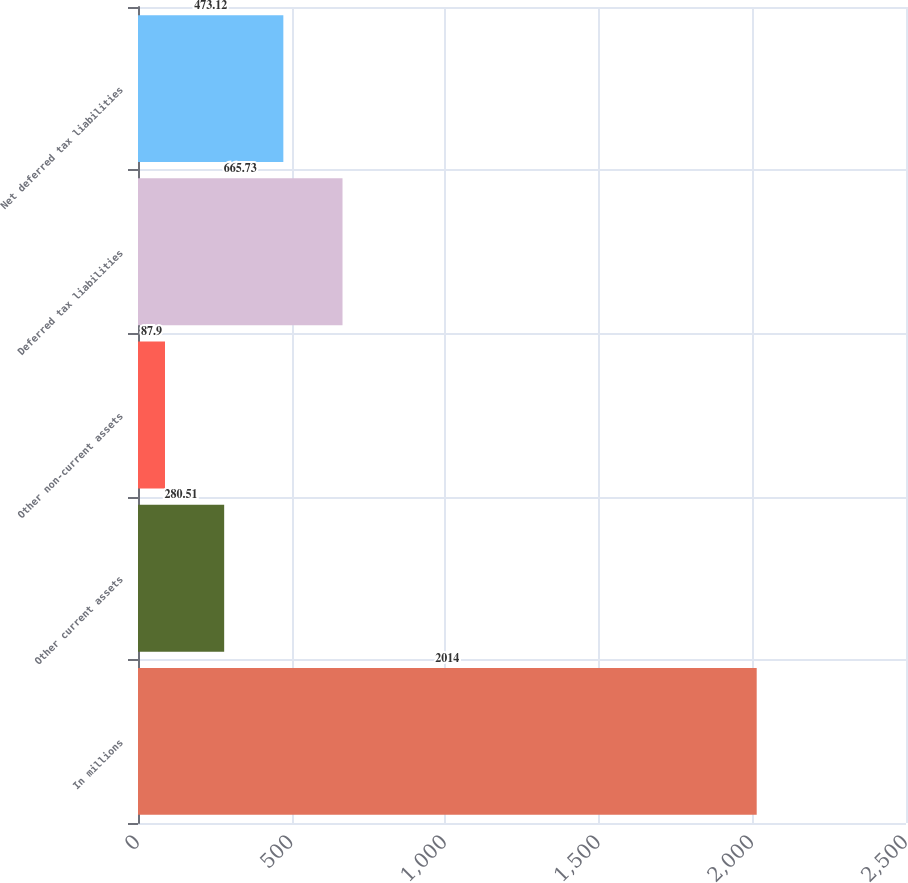Convert chart. <chart><loc_0><loc_0><loc_500><loc_500><bar_chart><fcel>In millions<fcel>Other current assets<fcel>Other non-current assets<fcel>Deferred tax liabilities<fcel>Net deferred tax liabilities<nl><fcel>2014<fcel>280.51<fcel>87.9<fcel>665.73<fcel>473.12<nl></chart> 